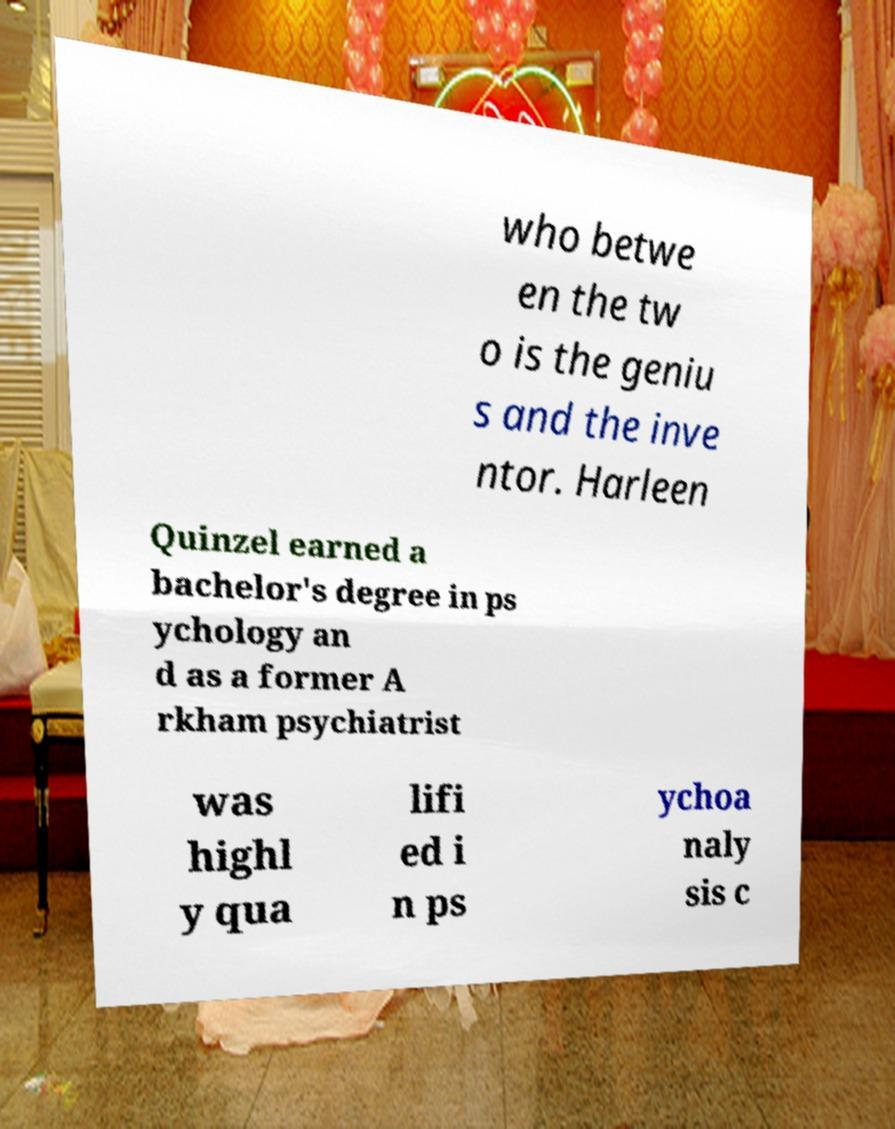Please read and relay the text visible in this image. What does it say? who betwe en the tw o is the geniu s and the inve ntor. Harleen Quinzel earned a bachelor's degree in ps ychology an d as a former A rkham psychiatrist was highl y qua lifi ed i n ps ychoa naly sis c 